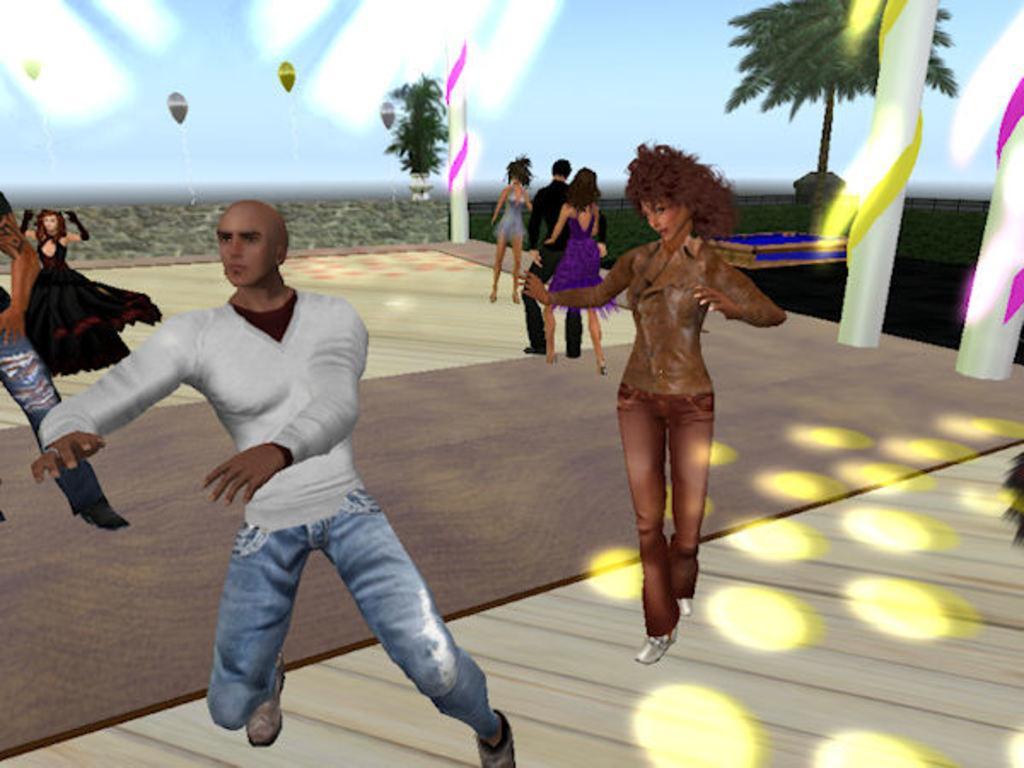Could you give a brief overview of what you see in this image? This image is an animation. In this image there are people. At the bottom we can see a carpet on the floor. There are pillars and we can see ribbons. There are trees. In the background there are balloons and we can see sky. 